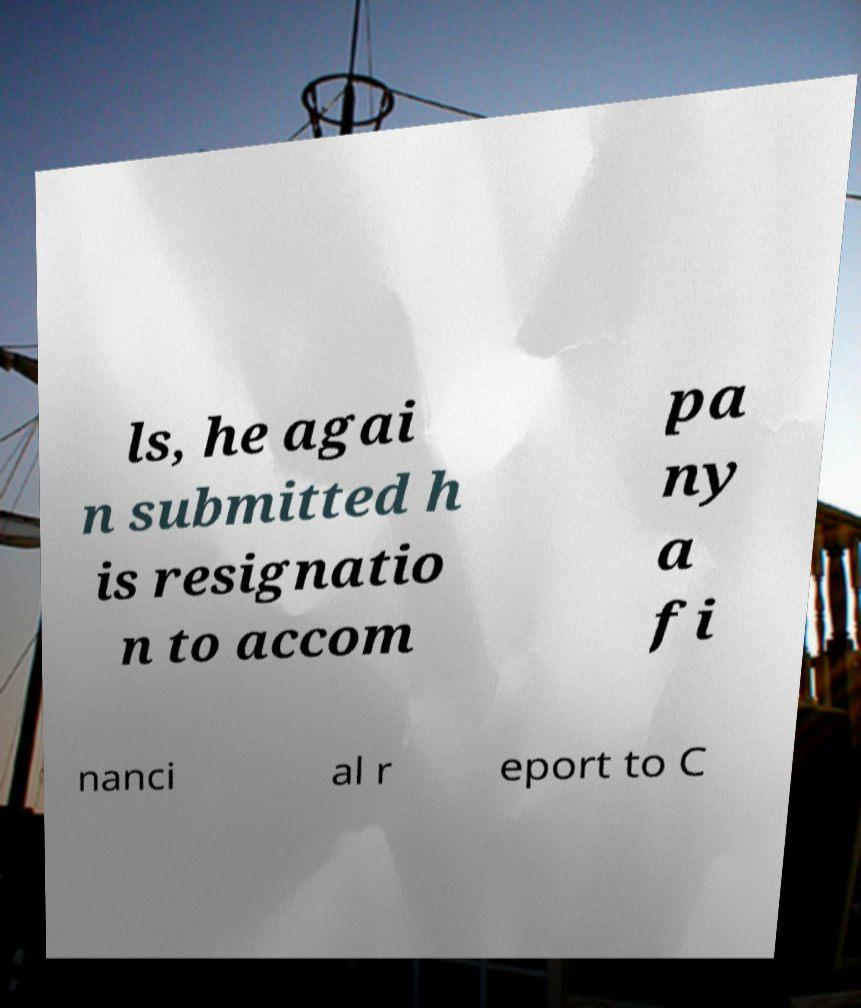For documentation purposes, I need the text within this image transcribed. Could you provide that? ls, he agai n submitted h is resignatio n to accom pa ny a fi nanci al r eport to C 